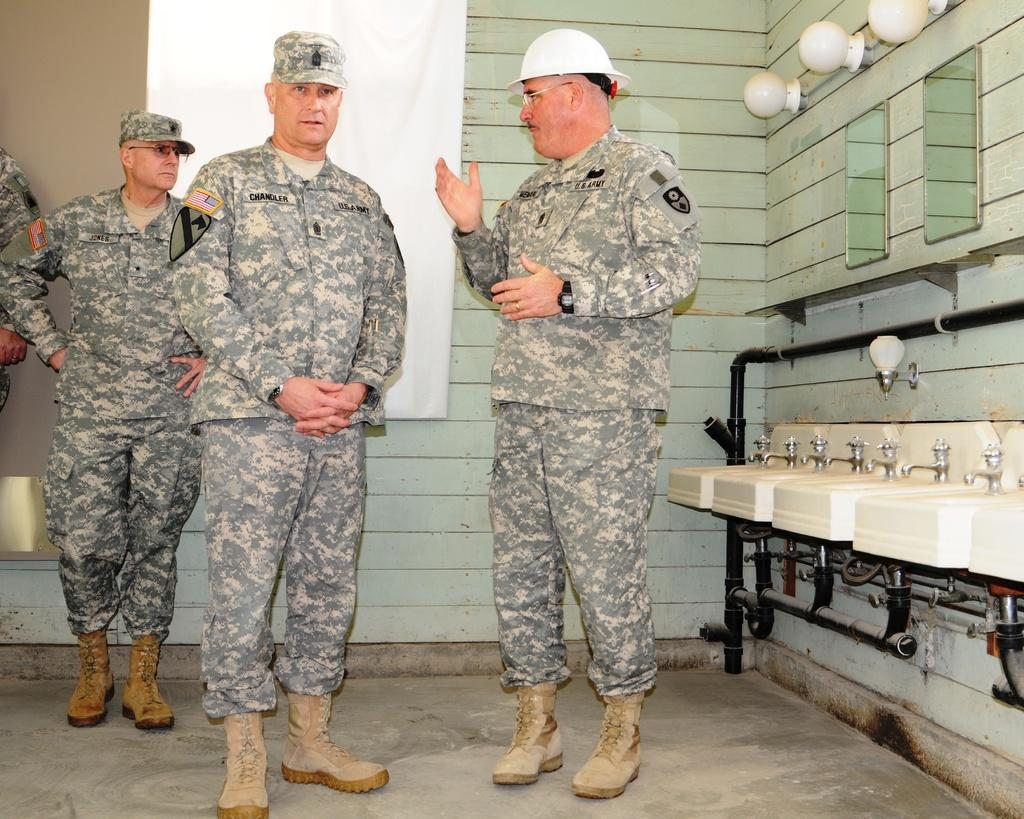What can be seen on the floor in the image? There are persons standing on the floor in the image. What is located on the right side of the image? On the right side of the image, there are sinks, taps, pipelines, mirrors, and electric lights. What is the price of the banana on the left side of the image? There is no banana present in the image. How many children are visible in the image? There is no mention of children in the provided facts, so we cannot determine their presence or number in the image. 